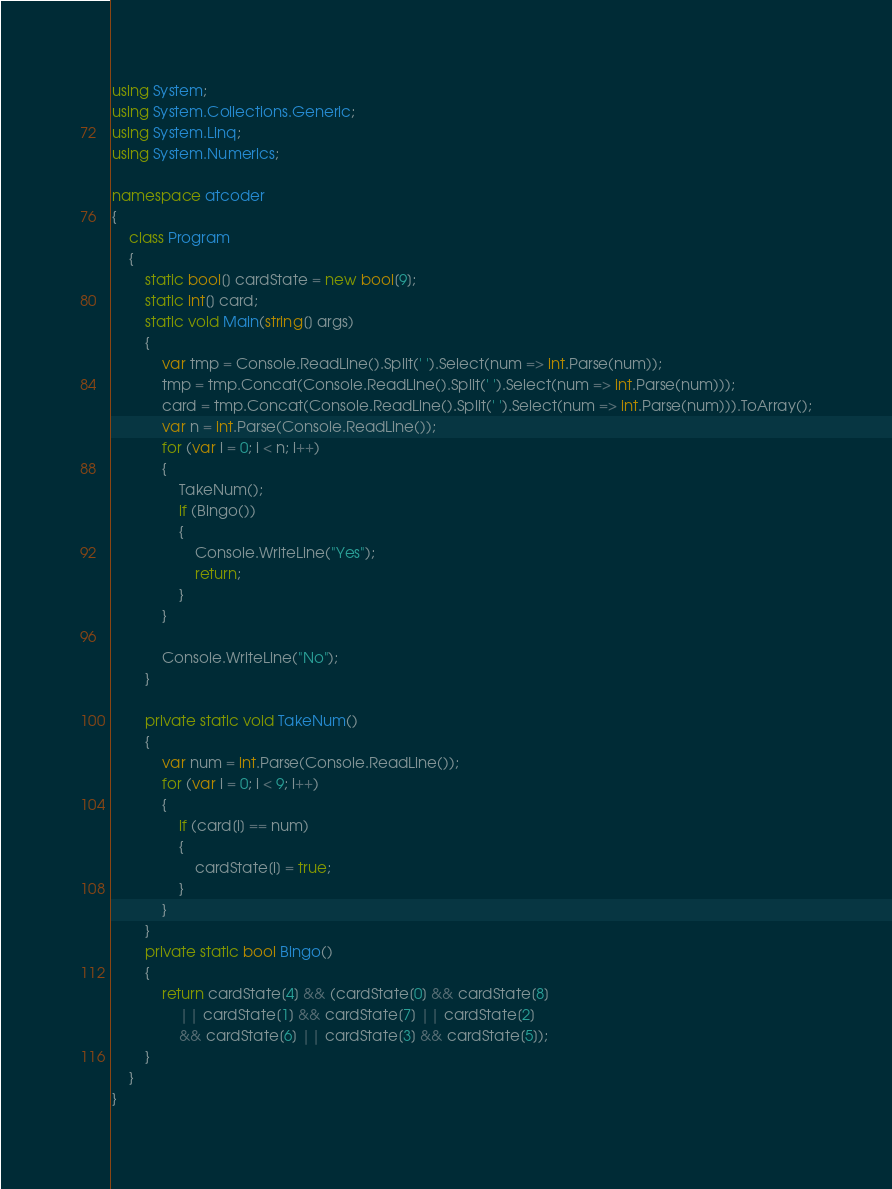Convert code to text. <code><loc_0><loc_0><loc_500><loc_500><_C#_>using System;
using System.Collections.Generic;
using System.Linq;
using System.Numerics;

namespace atcoder
{
    class Program
    {
        static bool[] cardState = new bool[9];
        static int[] card;
        static void Main(string[] args)
        {
            var tmp = Console.ReadLine().Split(' ').Select(num => int.Parse(num));
            tmp = tmp.Concat(Console.ReadLine().Split(' ').Select(num => int.Parse(num)));
            card = tmp.Concat(Console.ReadLine().Split(' ').Select(num => int.Parse(num))).ToArray();
            var n = int.Parse(Console.ReadLine());
            for (var i = 0; i < n; i++)
            {
                TakeNum();
                if (Bingo())
                {
                    Console.WriteLine("Yes");
                    return;
                }
            }

            Console.WriteLine("No");
        }

        private static void TakeNum()
        {
            var num = int.Parse(Console.ReadLine());
            for (var i = 0; i < 9; i++)
            {
                if (card[i] == num)
                {
                    cardState[i] = true;
                }
            }
        }
        private static bool Bingo()
        {
            return cardState[4] && (cardState[0] && cardState[8]
                || cardState[1] && cardState[7] || cardState[2]
                && cardState[6] || cardState[3] && cardState[5]);
        }
    }
}</code> 